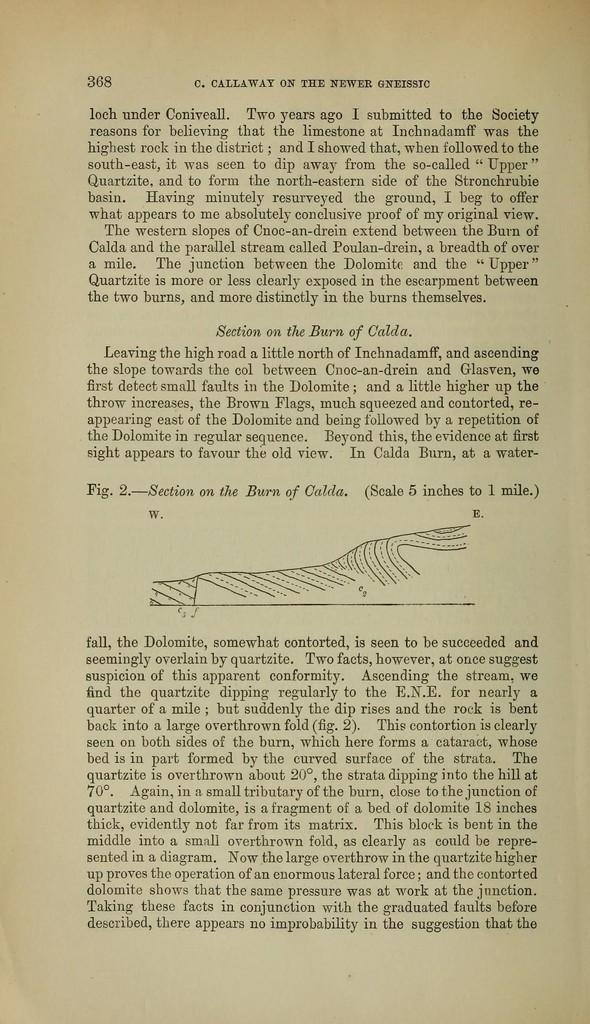<image>
Render a clear and concise summary of the photo. Page 368 from the text C. Callaway on the Newer Gneissic. 